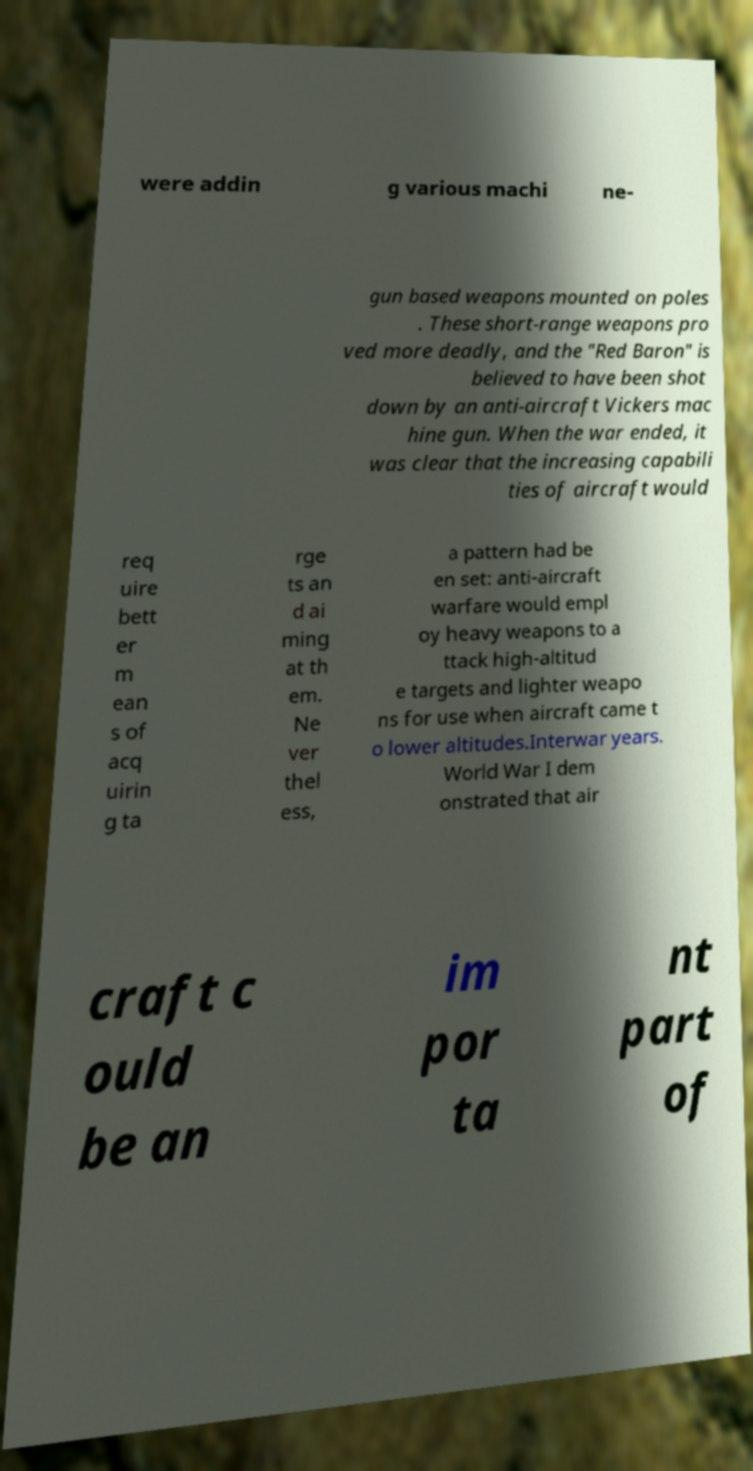What messages or text are displayed in this image? I need them in a readable, typed format. were addin g various machi ne- gun based weapons mounted on poles . These short-range weapons pro ved more deadly, and the "Red Baron" is believed to have been shot down by an anti-aircraft Vickers mac hine gun. When the war ended, it was clear that the increasing capabili ties of aircraft would req uire bett er m ean s of acq uirin g ta rge ts an d ai ming at th em. Ne ver thel ess, a pattern had be en set: anti-aircraft warfare would empl oy heavy weapons to a ttack high-altitud e targets and lighter weapo ns for use when aircraft came t o lower altitudes.Interwar years. World War I dem onstrated that air craft c ould be an im por ta nt part of 